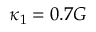<formula> <loc_0><loc_0><loc_500><loc_500>\kappa _ { 1 } = 0 . 7 G</formula> 